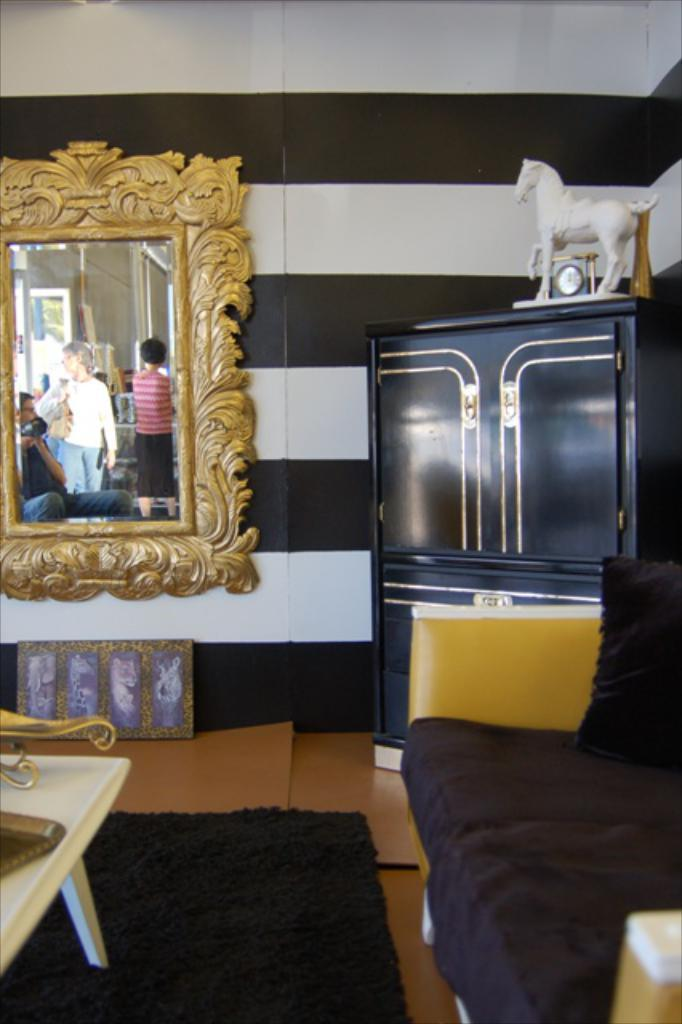What type of furniture is present in the image? There is a sofa, a table, and a cupboard in the image. What is on top of the cupboard? There is a toy on the cupboard. What can be used for self-reflection in the image? There is a mirror in the image. What type of flooring is visible at the bottom of the image? There is a carpet at the bottom of the image. What is the current ranking of the participants in the competition in the image? There is no competition present in the image, so there is no ranking to discuss. 